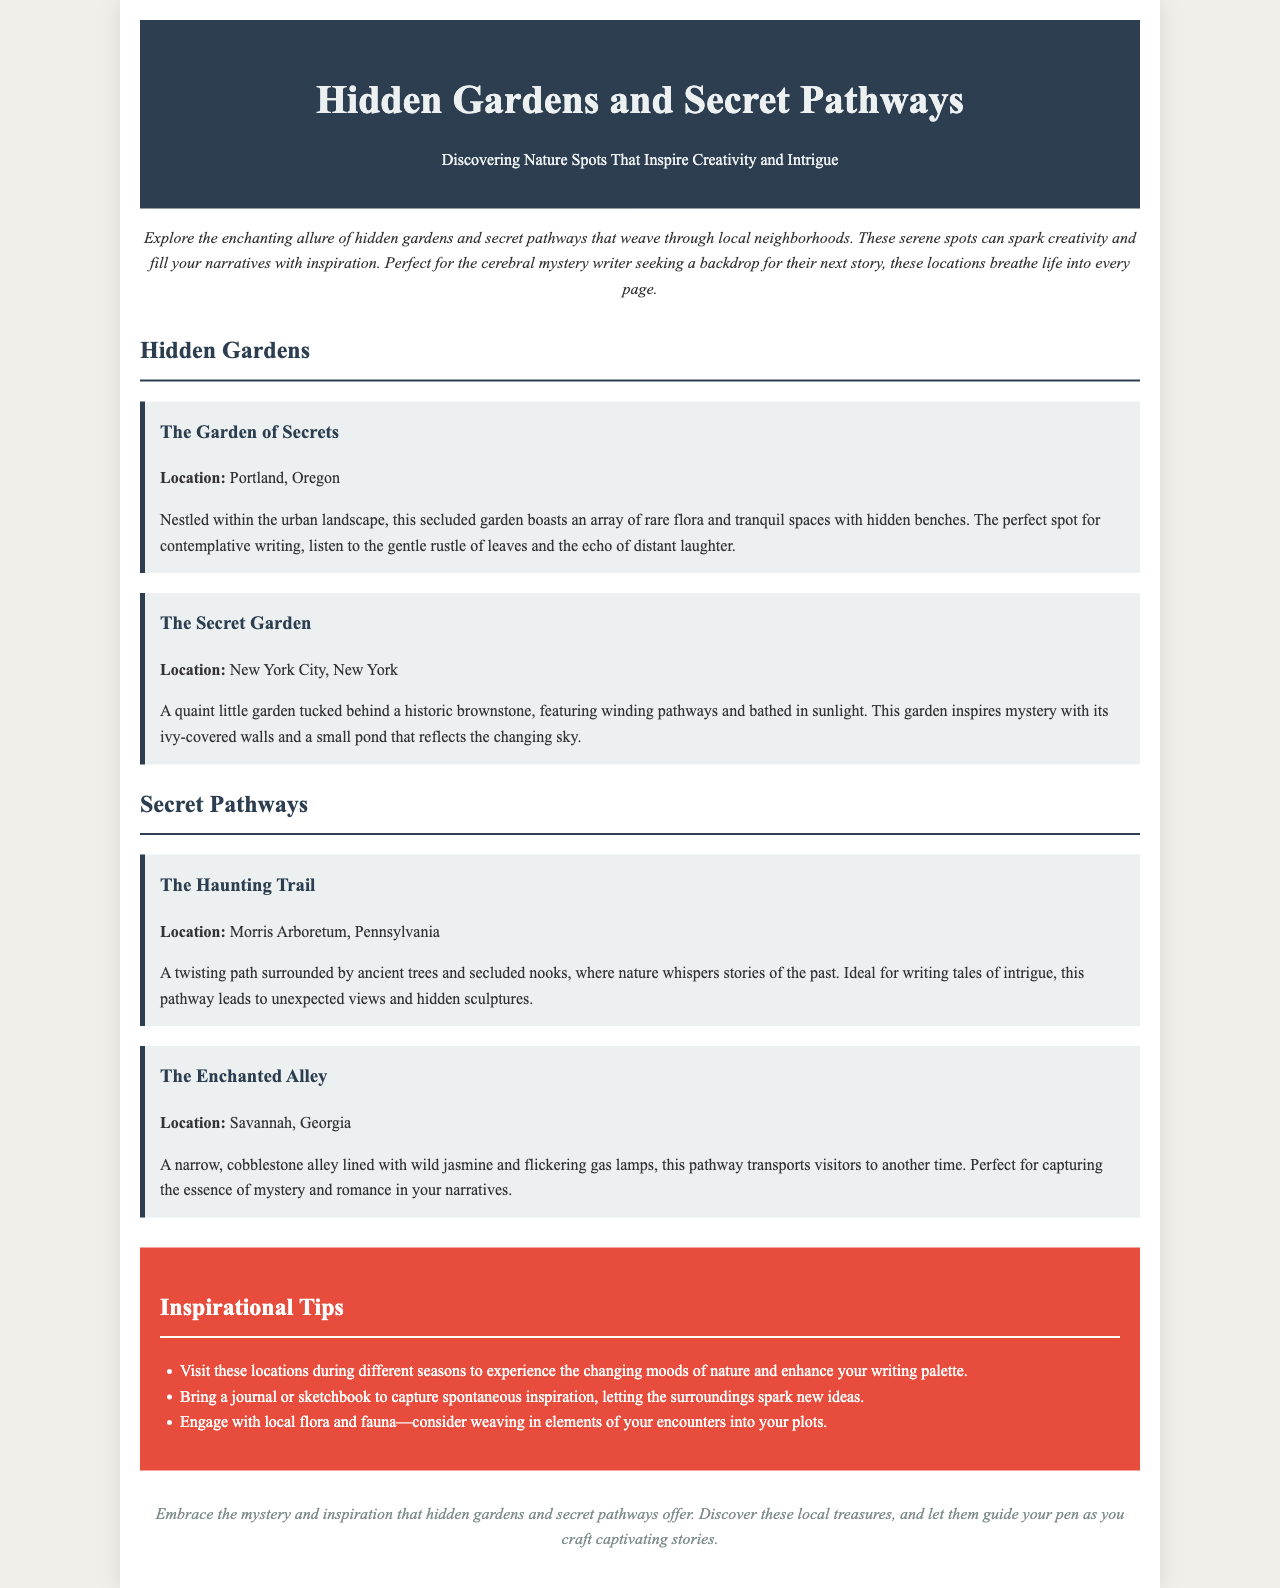What is the title of the brochure? The title is prominently displayed at the beginning of the document.
Answer: Hidden Gardens and Secret Pathways Where is The Garden of Secrets located? The specific location is mentioned in the description of The Garden of Secrets.
Answer: Portland, Oregon What inspires the essence of mystery and romance in narratives? The document highlights a specific pathway that embodies these themes.
Answer: The Enchanted Alley How many hidden gardens are mentioned in the brochure? The document lists two hidden gardens under the section titled "Hidden Gardens."
Answer: 2 What type of flora lines The Enchanted Alley? The brochure describes the flora associated with The Enchanted Alley.
Answer: Wild jasmine What is one of the tips for enhancing your writing palette? The tips section provides several suggestions for writers visiting the spots.
Answer: Visit these locations during different seasons What is the mood characterized by The Secret Garden? The description indicates the mood evoked by The Secret Garden.
Answer: Mystery Which location features a small pond? The document specifies a location that includes this feature.
Answer: The Secret Garden What type of document is this? The structure and content indicate the type of document.
Answer: Brochure 